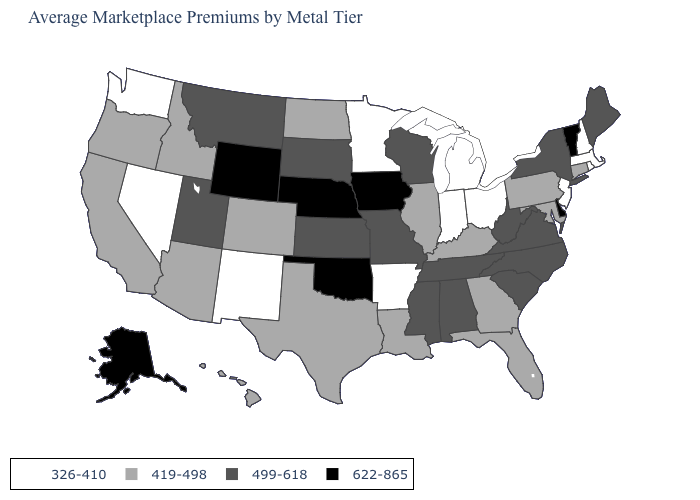Among the states that border Mississippi , which have the lowest value?
Concise answer only. Arkansas. Does Washington have the lowest value in the West?
Quick response, please. Yes. What is the value of Texas?
Quick response, please. 419-498. Among the states that border North Carolina , which have the lowest value?
Give a very brief answer. Georgia. Name the states that have a value in the range 499-618?
Keep it brief. Alabama, Kansas, Maine, Mississippi, Missouri, Montana, New York, North Carolina, South Carolina, South Dakota, Tennessee, Utah, Virginia, West Virginia, Wisconsin. Name the states that have a value in the range 419-498?
Be succinct. Arizona, California, Colorado, Connecticut, Florida, Georgia, Hawaii, Idaho, Illinois, Kentucky, Louisiana, Maryland, North Dakota, Oregon, Pennsylvania, Texas. What is the value of Iowa?
Give a very brief answer. 622-865. What is the value of Washington?
Keep it brief. 326-410. Among the states that border Montana , does Idaho have the highest value?
Quick response, please. No. What is the lowest value in the MidWest?
Quick response, please. 326-410. What is the value of Mississippi?
Answer briefly. 499-618. Does Alabama have the lowest value in the USA?
Answer briefly. No. Which states hav the highest value in the MidWest?
Quick response, please. Iowa, Nebraska. What is the value of Connecticut?
Quick response, please. 419-498. 